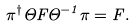<formula> <loc_0><loc_0><loc_500><loc_500>\pi ^ { \dagger } \Theta F \Theta ^ { - 1 } \pi = F .</formula> 